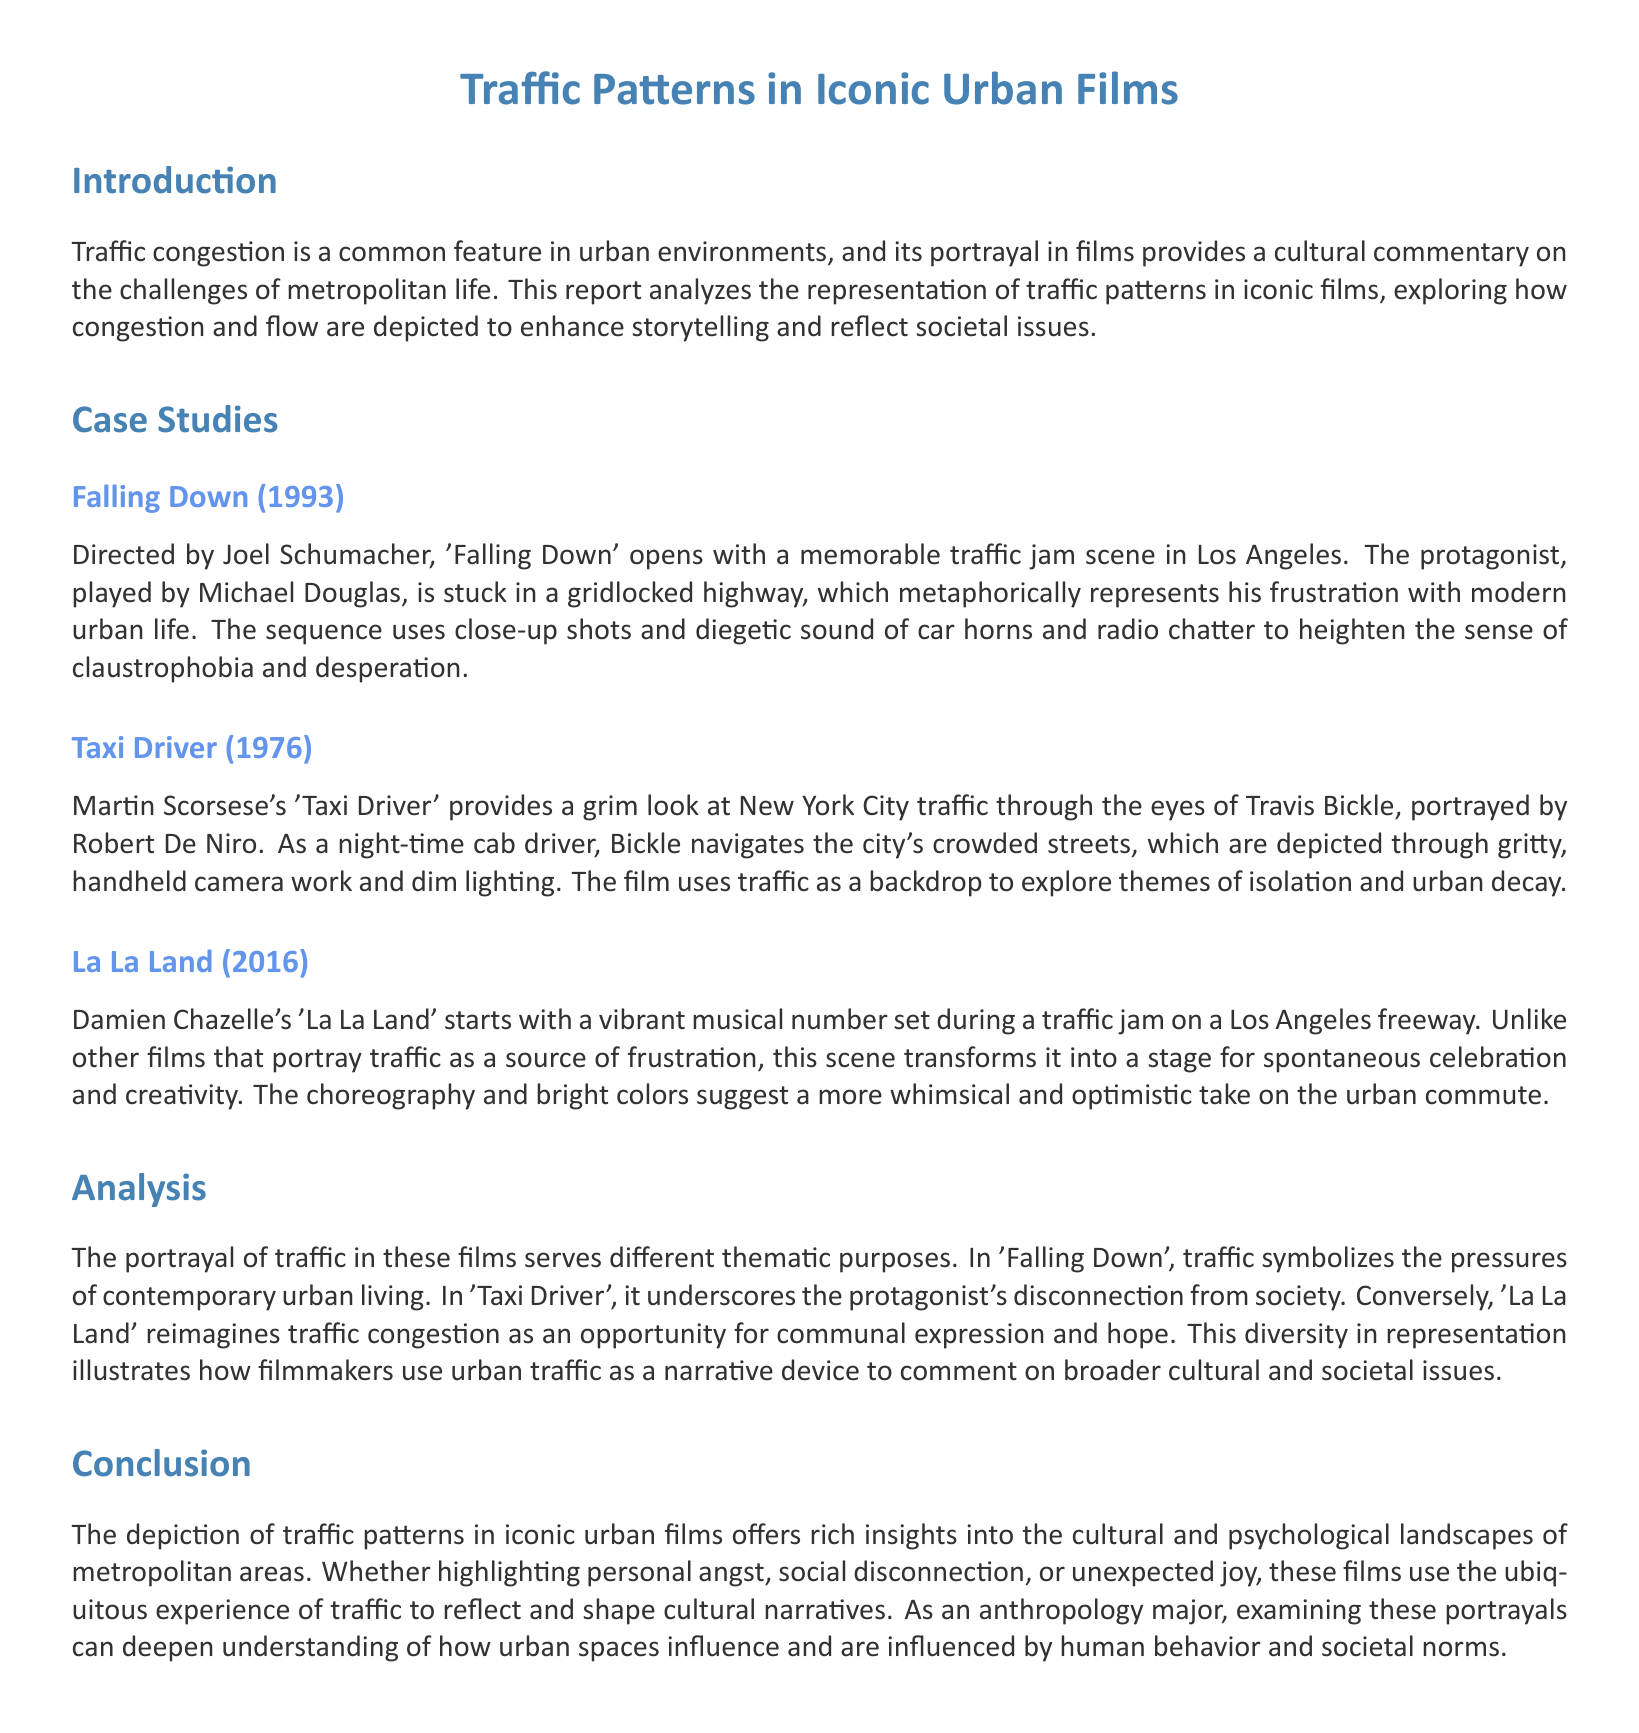What film features a notable traffic jam scene in Los Angeles? The document specifies that 'Falling Down' opens with a memorable traffic jam scene in Los Angeles, highlighting congestion in urban life.
Answer: Falling Down Who directed 'Taxi Driver'? The document identifies Martin Scorsese as the director of 'Taxi Driver'.
Answer: Martin Scorsese What year was 'La La Land' released? The document states that 'La La Land' was released in 2016, providing a specific date relevant to the film's analysis.
Answer: 2016 What theme is explored through traffic in 'Falling Down'? According to the document, traffic in 'Falling Down' symbolizes the pressures of contemporary urban living, indicating deeper societal commentary.
Answer: Pressures of contemporary urban living Which film depicts traffic as a stage for celebration? The document highlights that 'La La Land' transforms traffic into a stage for spontaneous celebration and creativity, diverging from typical portrayals.
Answer: La La Land What is the cinematographic style used in 'Taxi Driver'? The document describes that 'Taxi Driver' utilizes gritty, handheld camera work and dim lighting to capture the essence of New York City traffic.
Answer: Gritty, handheld camera work What unique perspective does 'La La Land' offer on traffic patterns? The document mentions that 'La La Land' offers a whimsical and optimistic take on traffic, contrasting with other films that depict it negatively.
Answer: Whimsical and optimistic What do the traffic patterns in iconic urban films reflect? The document asserts that traffic patterns in these films reflect and shape cultural narratives, highlighting their significance in the portrayal of urban life.
Answer: Cultural narratives 